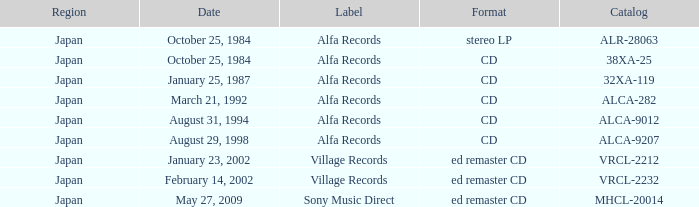What is the area of distribution for a cd with catalog 32xa-119? Japan. 